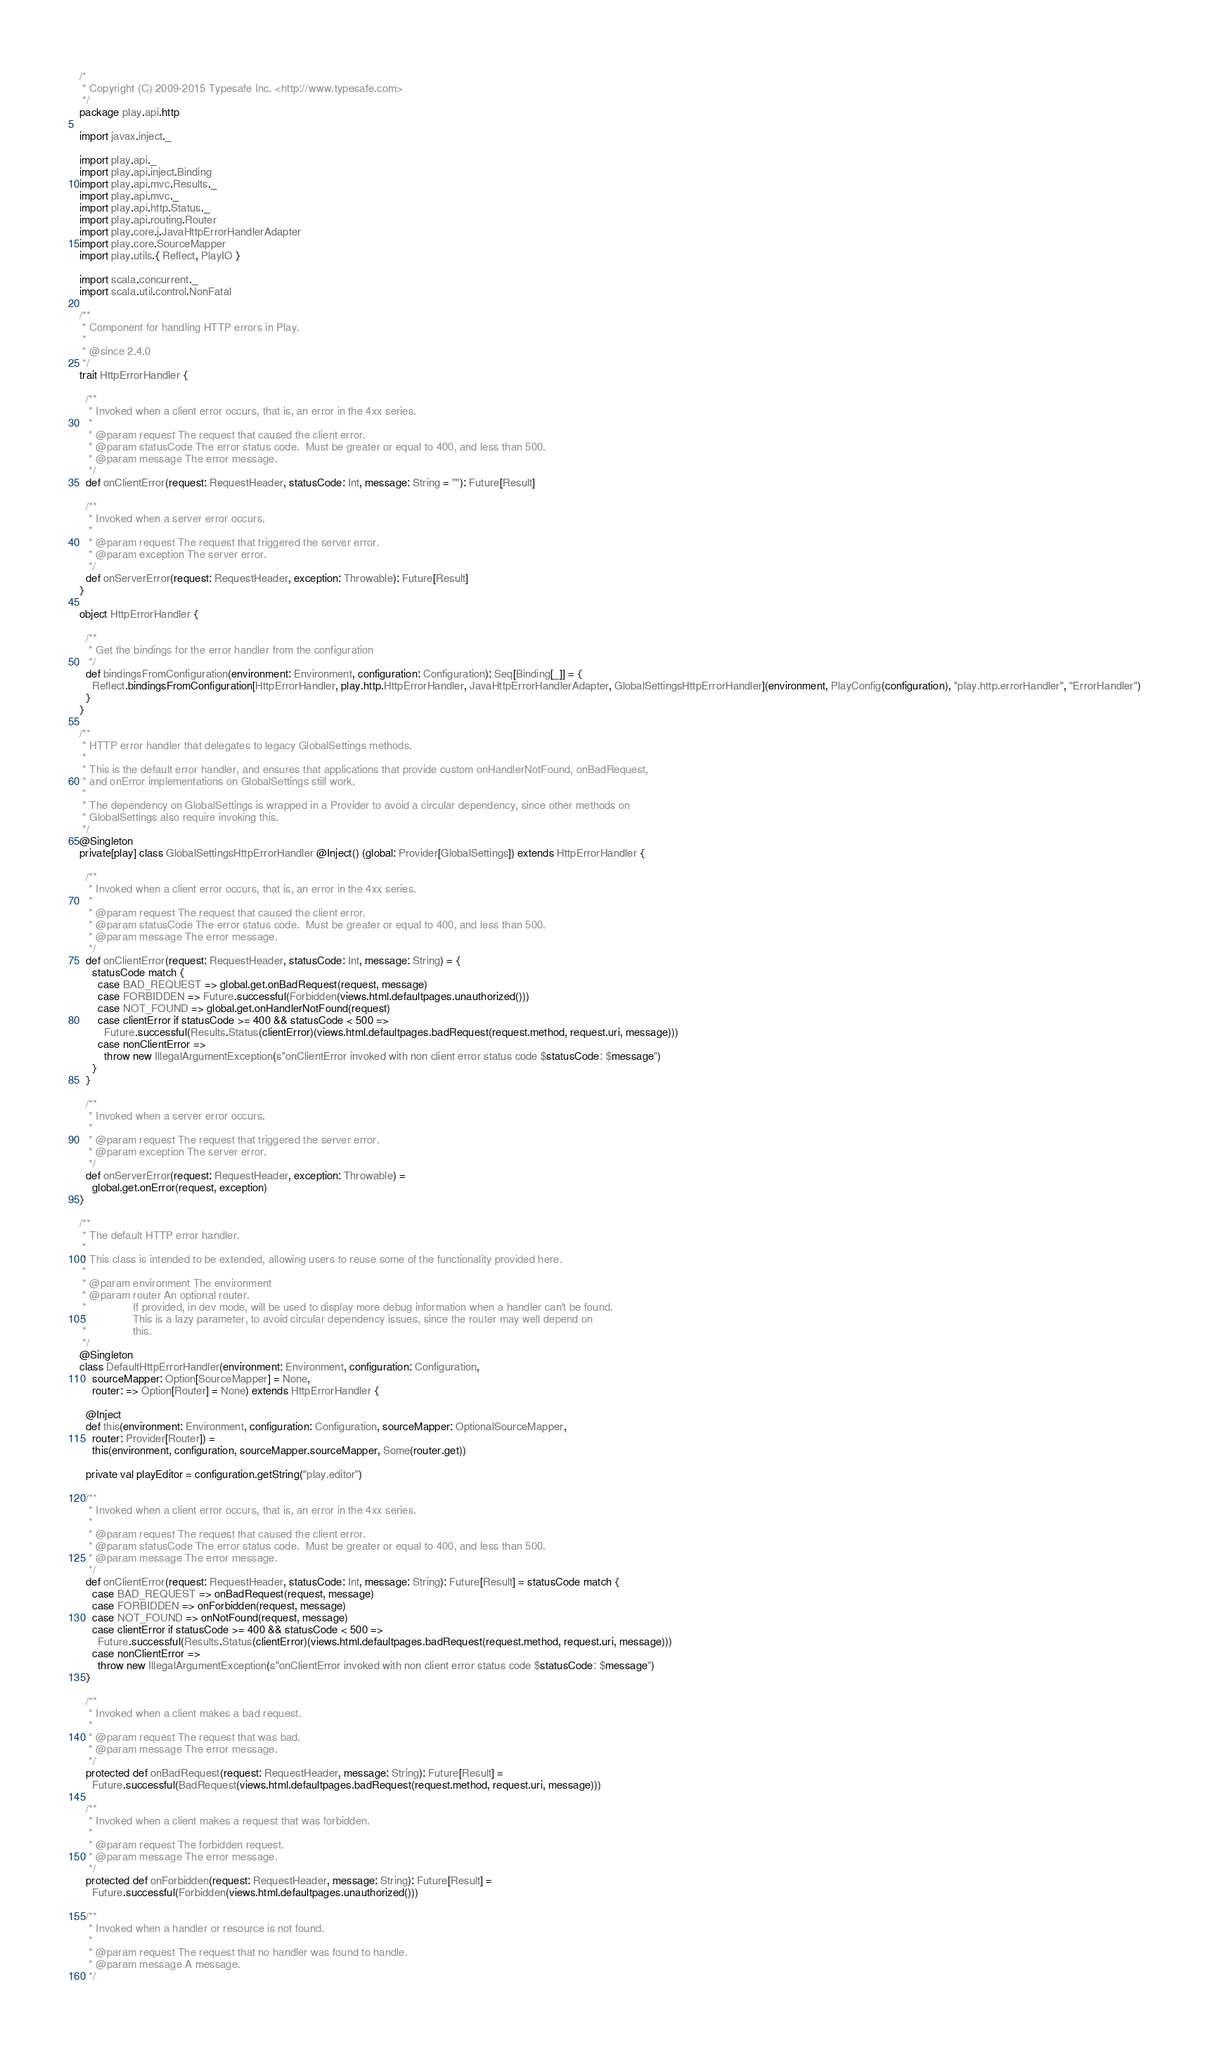Convert code to text. <code><loc_0><loc_0><loc_500><loc_500><_Scala_>/*
 * Copyright (C) 2009-2015 Typesafe Inc. <http://www.typesafe.com>
 */
package play.api.http

import javax.inject._

import play.api._
import play.api.inject.Binding
import play.api.mvc.Results._
import play.api.mvc._
import play.api.http.Status._
import play.api.routing.Router
import play.core.j.JavaHttpErrorHandlerAdapter
import play.core.SourceMapper
import play.utils.{ Reflect, PlayIO }

import scala.concurrent._
import scala.util.control.NonFatal

/**
 * Component for handling HTTP errors in Play.
 *
 * @since 2.4.0
 */
trait HttpErrorHandler {

  /**
   * Invoked when a client error occurs, that is, an error in the 4xx series.
   *
   * @param request The request that caused the client error.
   * @param statusCode The error status code.  Must be greater or equal to 400, and less than 500.
   * @param message The error message.
   */
  def onClientError(request: RequestHeader, statusCode: Int, message: String = ""): Future[Result]

  /**
   * Invoked when a server error occurs.
   *
   * @param request The request that triggered the server error.
   * @param exception The server error.
   */
  def onServerError(request: RequestHeader, exception: Throwable): Future[Result]
}

object HttpErrorHandler {

  /**
   * Get the bindings for the error handler from the configuration
   */
  def bindingsFromConfiguration(environment: Environment, configuration: Configuration): Seq[Binding[_]] = {
    Reflect.bindingsFromConfiguration[HttpErrorHandler, play.http.HttpErrorHandler, JavaHttpErrorHandlerAdapter, GlobalSettingsHttpErrorHandler](environment, PlayConfig(configuration), "play.http.errorHandler", "ErrorHandler")
  }
}

/**
 * HTTP error handler that delegates to legacy GlobalSettings methods.
 *
 * This is the default error handler, and ensures that applications that provide custom onHandlerNotFound, onBadRequest,
 * and onError implementations on GlobalSettings still work.
 *
 * The dependency on GlobalSettings is wrapped in a Provider to avoid a circular dependency, since other methods on
 * GlobalSettings also require invoking this.
 */
@Singleton
private[play] class GlobalSettingsHttpErrorHandler @Inject() (global: Provider[GlobalSettings]) extends HttpErrorHandler {

  /**
   * Invoked when a client error occurs, that is, an error in the 4xx series.
   *
   * @param request The request that caused the client error.
   * @param statusCode The error status code.  Must be greater or equal to 400, and less than 500.
   * @param message The error message.
   */
  def onClientError(request: RequestHeader, statusCode: Int, message: String) = {
    statusCode match {
      case BAD_REQUEST => global.get.onBadRequest(request, message)
      case FORBIDDEN => Future.successful(Forbidden(views.html.defaultpages.unauthorized()))
      case NOT_FOUND => global.get.onHandlerNotFound(request)
      case clientError if statusCode >= 400 && statusCode < 500 =>
        Future.successful(Results.Status(clientError)(views.html.defaultpages.badRequest(request.method, request.uri, message)))
      case nonClientError =>
        throw new IllegalArgumentException(s"onClientError invoked with non client error status code $statusCode: $message")
    }
  }

  /**
   * Invoked when a server error occurs.
   *
   * @param request The request that triggered the server error.
   * @param exception The server error.
   */
  def onServerError(request: RequestHeader, exception: Throwable) =
    global.get.onError(request, exception)
}

/**
 * The default HTTP error handler.
 *
 * This class is intended to be extended, allowing users to reuse some of the functionality provided here.
 *
 * @param environment The environment
 * @param router An optional router.
 *               If provided, in dev mode, will be used to display more debug information when a handler can't be found.
 *               This is a lazy parameter, to avoid circular dependency issues, since the router may well depend on
 *               this.
 */
@Singleton
class DefaultHttpErrorHandler(environment: Environment, configuration: Configuration,
    sourceMapper: Option[SourceMapper] = None,
    router: => Option[Router] = None) extends HttpErrorHandler {

  @Inject
  def this(environment: Environment, configuration: Configuration, sourceMapper: OptionalSourceMapper,
    router: Provider[Router]) =
    this(environment, configuration, sourceMapper.sourceMapper, Some(router.get))

  private val playEditor = configuration.getString("play.editor")

  /**
   * Invoked when a client error occurs, that is, an error in the 4xx series.
   *
   * @param request The request that caused the client error.
   * @param statusCode The error status code.  Must be greater or equal to 400, and less than 500.
   * @param message The error message.
   */
  def onClientError(request: RequestHeader, statusCode: Int, message: String): Future[Result] = statusCode match {
    case BAD_REQUEST => onBadRequest(request, message)
    case FORBIDDEN => onForbidden(request, message)
    case NOT_FOUND => onNotFound(request, message)
    case clientError if statusCode >= 400 && statusCode < 500 =>
      Future.successful(Results.Status(clientError)(views.html.defaultpages.badRequest(request.method, request.uri, message)))
    case nonClientError =>
      throw new IllegalArgumentException(s"onClientError invoked with non client error status code $statusCode: $message")
  }

  /**
   * Invoked when a client makes a bad request.
   *
   * @param request The request that was bad.
   * @param message The error message.
   */
  protected def onBadRequest(request: RequestHeader, message: String): Future[Result] =
    Future.successful(BadRequest(views.html.defaultpages.badRequest(request.method, request.uri, message)))

  /**
   * Invoked when a client makes a request that was forbidden.
   *
   * @param request The forbidden request.
   * @param message The error message.
   */
  protected def onForbidden(request: RequestHeader, message: String): Future[Result] =
    Future.successful(Forbidden(views.html.defaultpages.unauthorized()))

  /**
   * Invoked when a handler or resource is not found.
   *
   * @param request The request that no handler was found to handle.
   * @param message A message.
   */</code> 